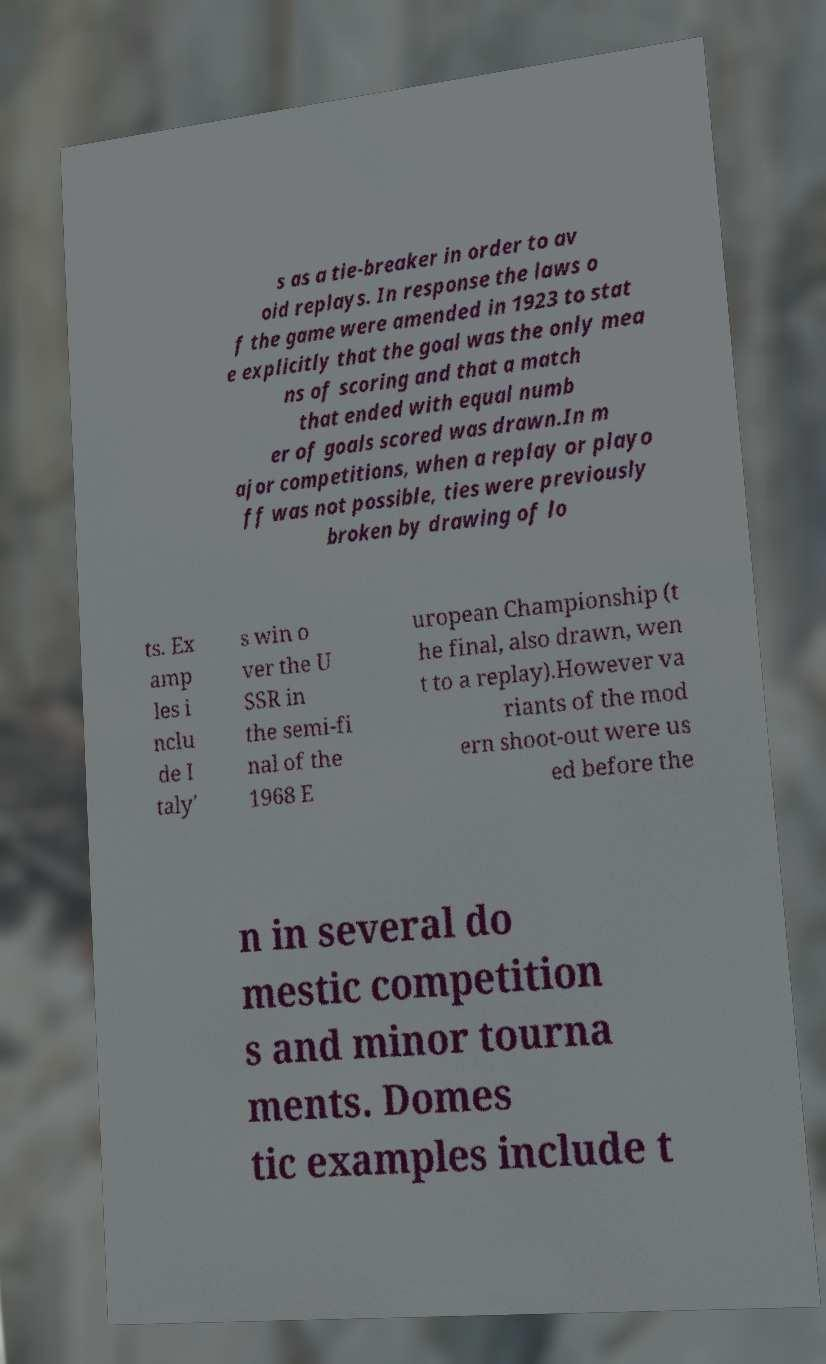Can you read and provide the text displayed in the image?This photo seems to have some interesting text. Can you extract and type it out for me? s as a tie-breaker in order to av oid replays. In response the laws o f the game were amended in 1923 to stat e explicitly that the goal was the only mea ns of scoring and that a match that ended with equal numb er of goals scored was drawn.In m ajor competitions, when a replay or playo ff was not possible, ties were previously broken by drawing of lo ts. Ex amp les i nclu de I taly' s win o ver the U SSR in the semi-fi nal of the 1968 E uropean Championship (t he final, also drawn, wen t to a replay).However va riants of the mod ern shoot-out were us ed before the n in several do mestic competition s and minor tourna ments. Domes tic examples include t 